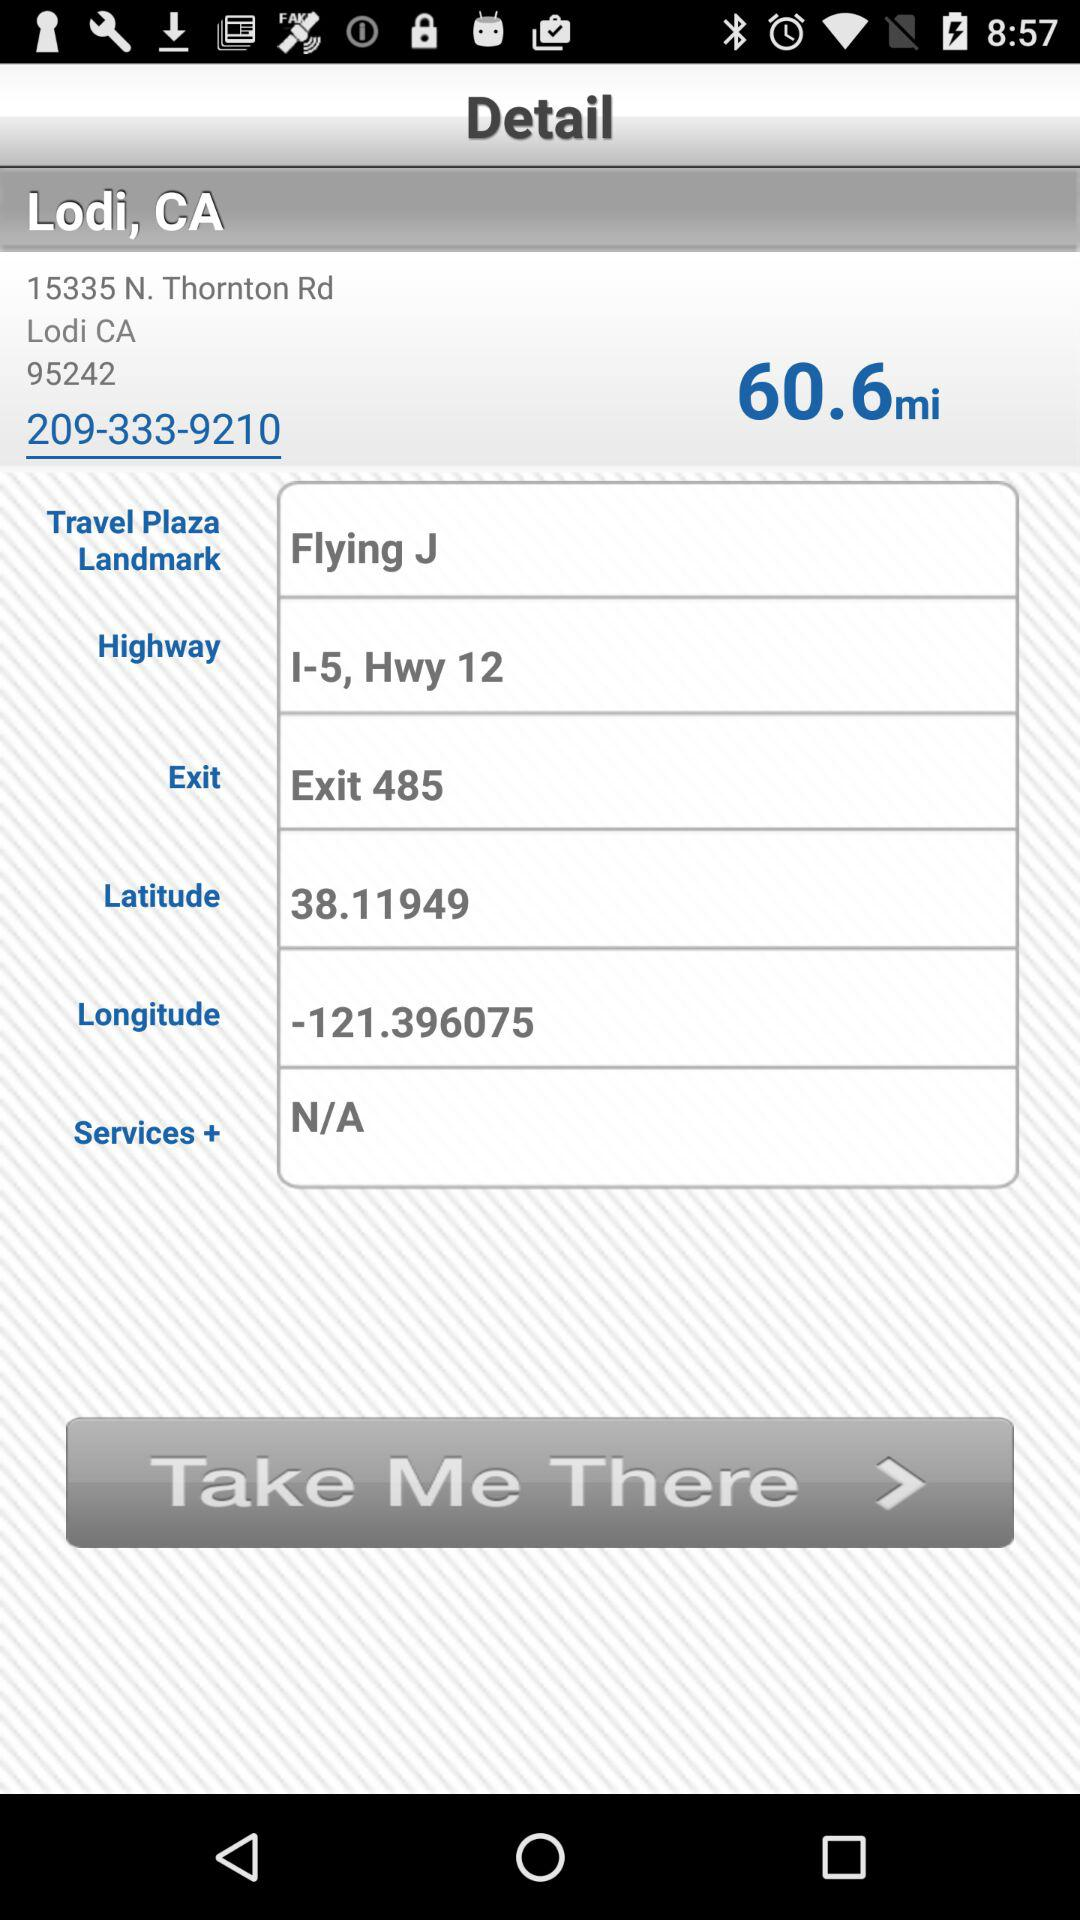What is the contact number? The contact number is 209-333-9210. 